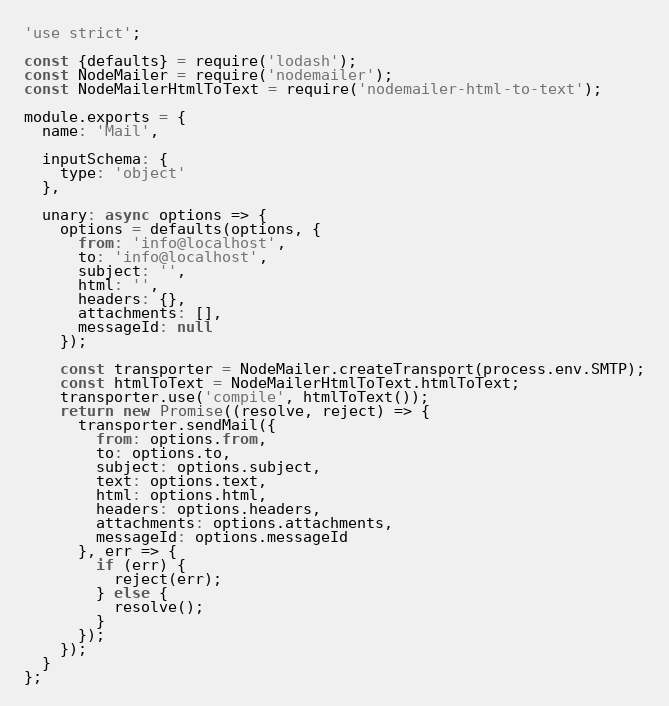Convert code to text. <code><loc_0><loc_0><loc_500><loc_500><_JavaScript_>'use strict';

const {defaults} = require('lodash');
const NodeMailer = require('nodemailer');
const NodeMailerHtmlToText = require('nodemailer-html-to-text');

module.exports = {
  name: 'Mail',

  inputSchema: {
    type: 'object'
  },

  unary: async options => {
    options = defaults(options, {
      from: 'info@localhost',
      to: 'info@localhost',
      subject: '',
      html: '',
      headers: {},
      attachments: [],
      messageId: null
    });

    const transporter = NodeMailer.createTransport(process.env.SMTP);
    const htmlToText = NodeMailerHtmlToText.htmlToText;
    transporter.use('compile', htmlToText());
    return new Promise((resolve, reject) => {
      transporter.sendMail({
        from: options.from,
        to: options.to,
        subject: options.subject,
        text: options.text,
        html: options.html,
        headers: options.headers,
        attachments: options.attachments,
        messageId: options.messageId
      }, err => {
        if (err) {
          reject(err);
        } else {
          resolve();
        }
      });
    });
  }
};
</code> 